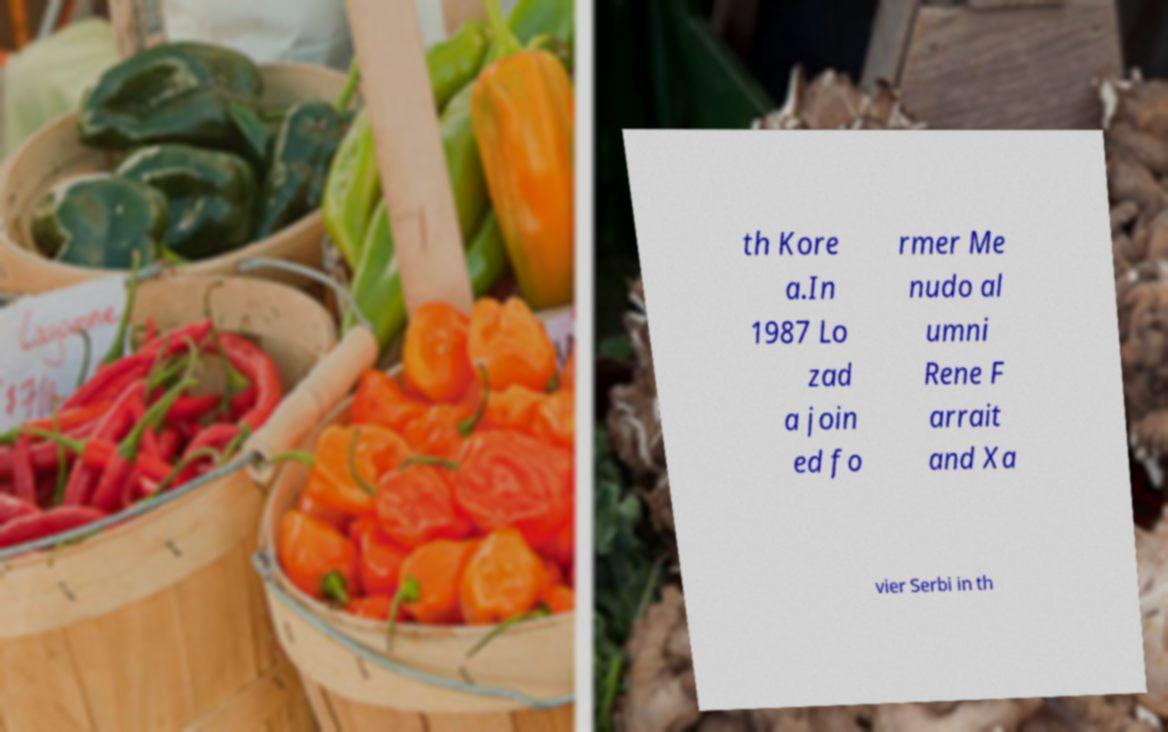Please read and relay the text visible in this image. What does it say? th Kore a.In 1987 Lo zad a join ed fo rmer Me nudo al umni Rene F arrait and Xa vier Serbi in th 